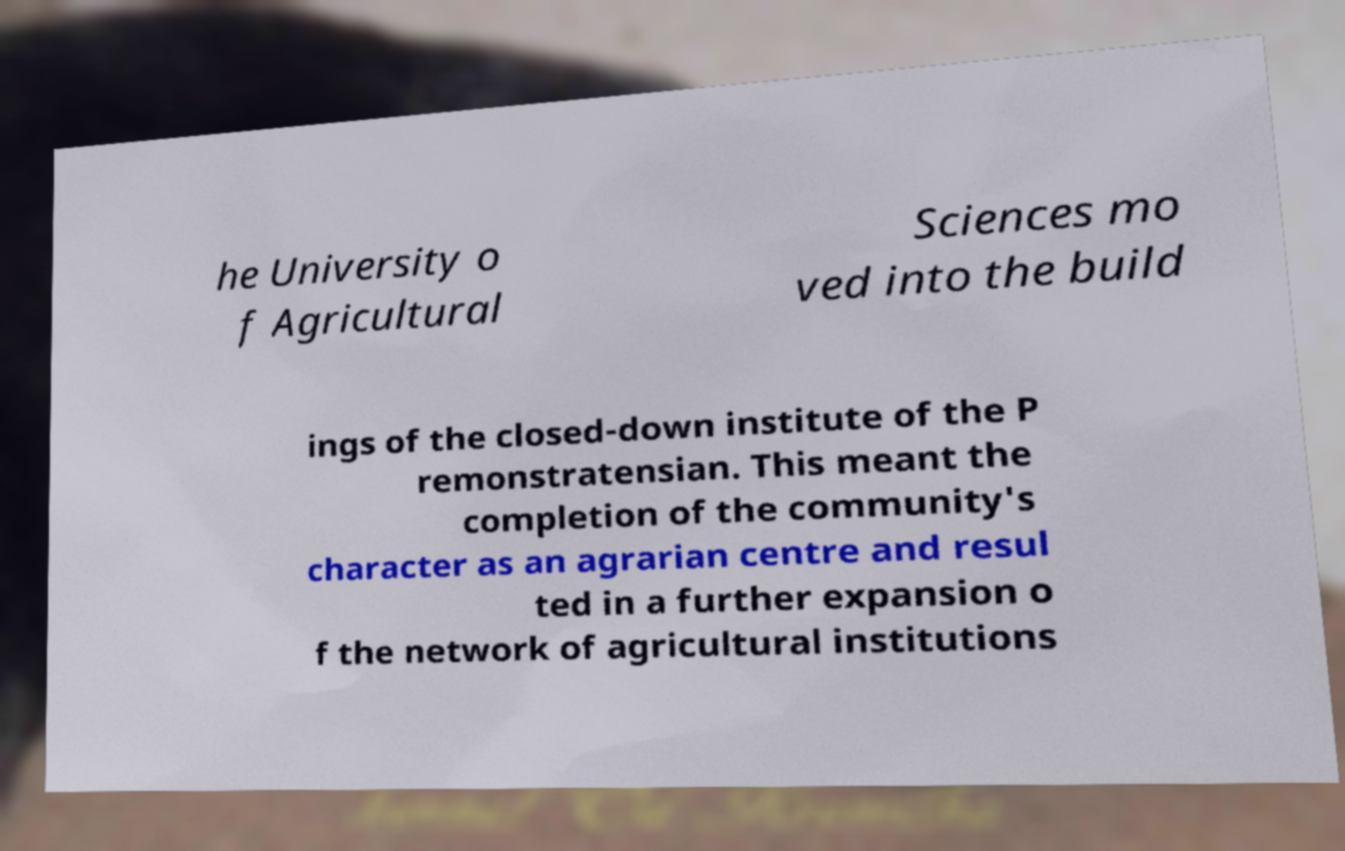Could you assist in decoding the text presented in this image and type it out clearly? he University o f Agricultural Sciences mo ved into the build ings of the closed-down institute of the P remonstratensian. This meant the completion of the community's character as an agrarian centre and resul ted in a further expansion o f the network of agricultural institutions 